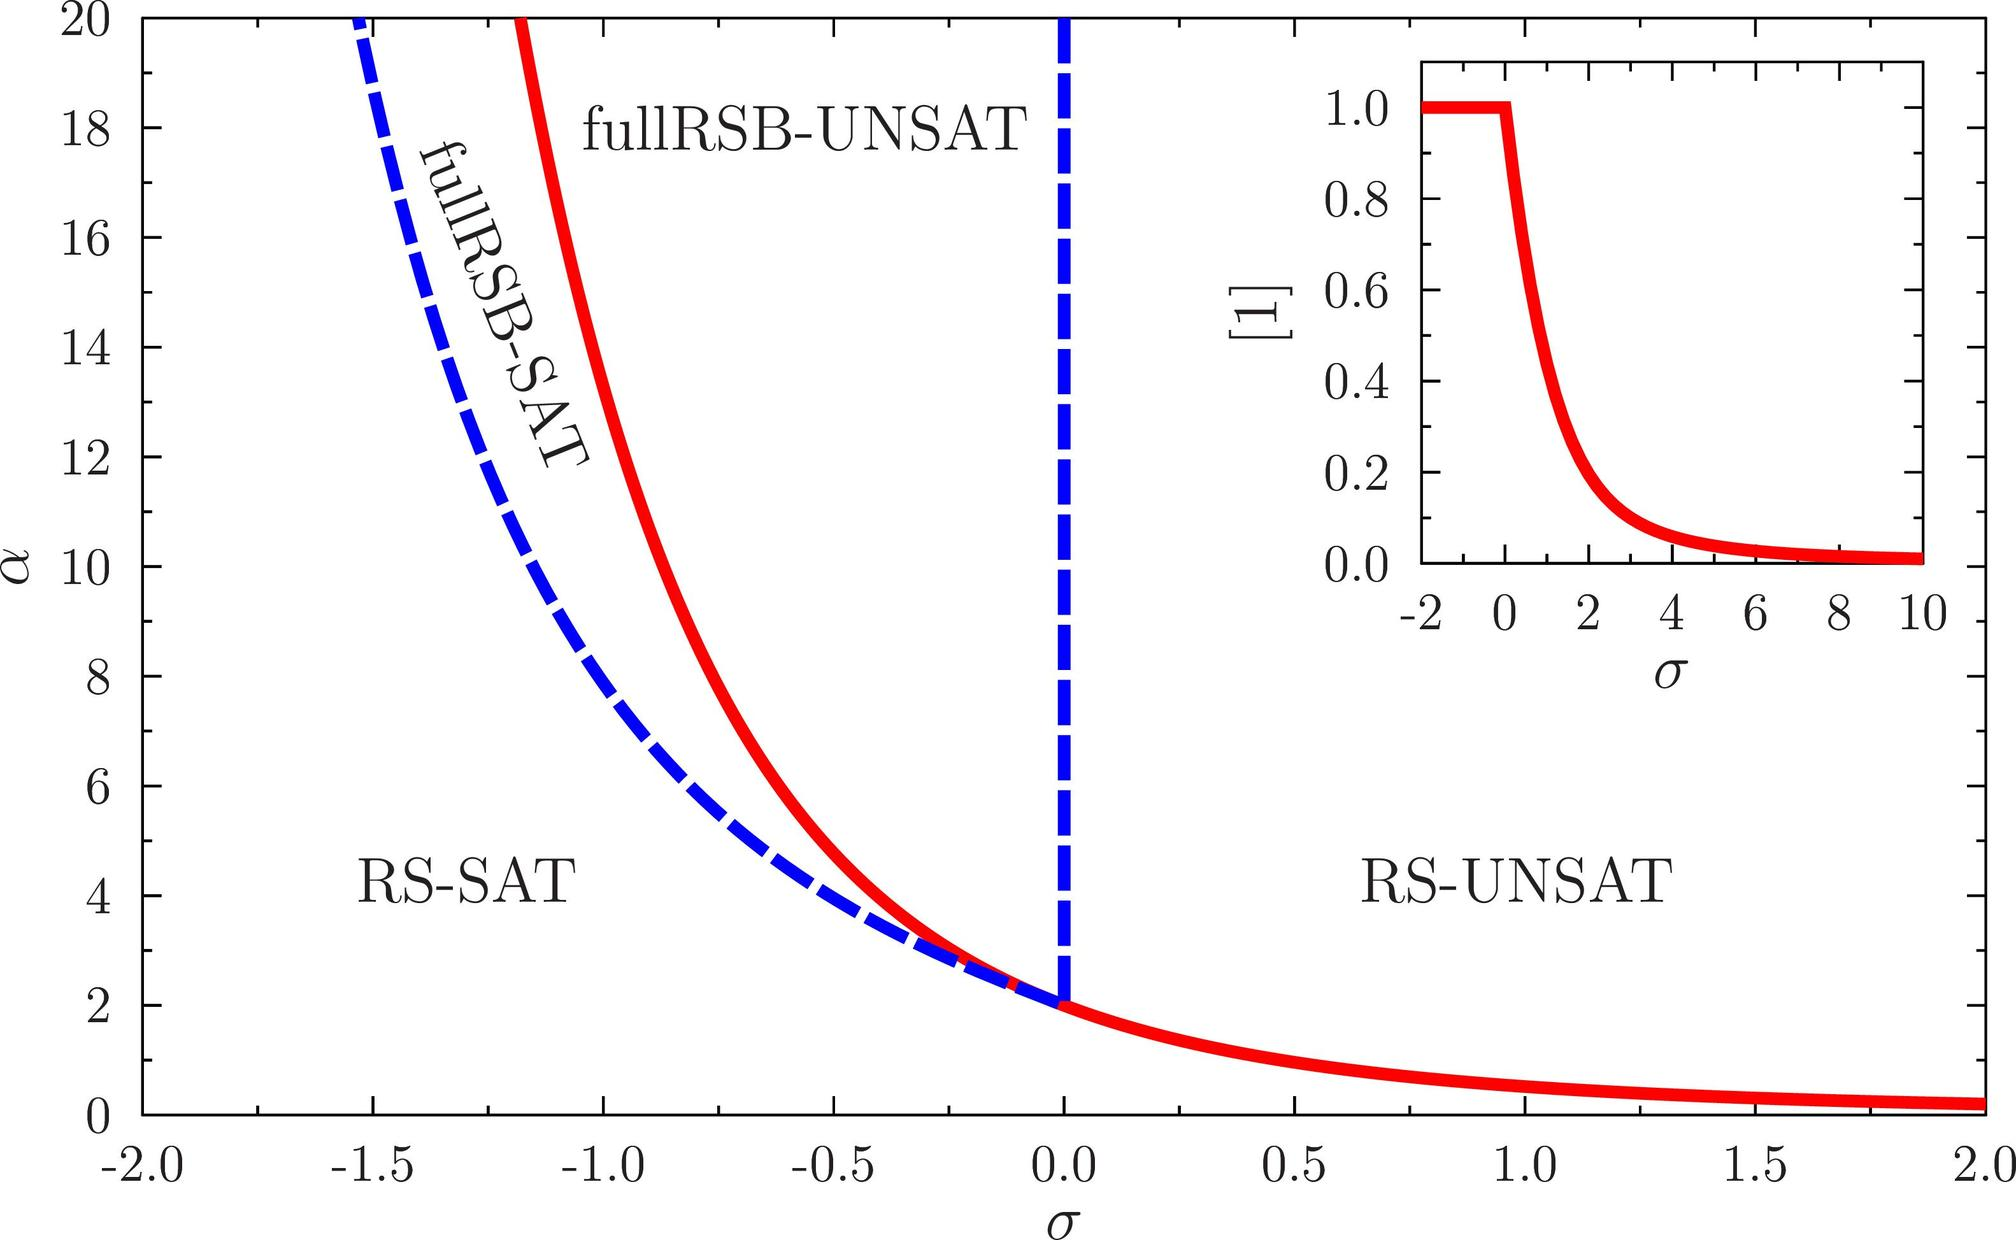What is the significance of the blue dashed line in the graph? The blue dashed line in the graph demarcates two distinct regions, namely RS-SAT and fullRSB-UNSAT, which are crucial for understanding the theoretical underpinnings of the Random Satisfaction (RS) model. This line signifies a theoretical threshold where the nature of solutions transitions from being potentially solvable (RS-Satisfiable) to definitely unsolvable (full Replica Symmetry Breaking-Unsatisfiable), thus providing critical insight into the limits of satisfiability under increasing complexity. How can this graph be applied in practical scenarios? This graph can be practically applied in computational and statistical physics, particularly in areas involving optimization problems, machine learning, and other complex systems where understanding the boundary conditions is crucial for algorithm design or system analysis. By identifying the regions of satisfiability, researchers can optimize algorithms to work within these parameters, enhancing efficiency and effectiveness in solving real-world problems faced in these fields. 